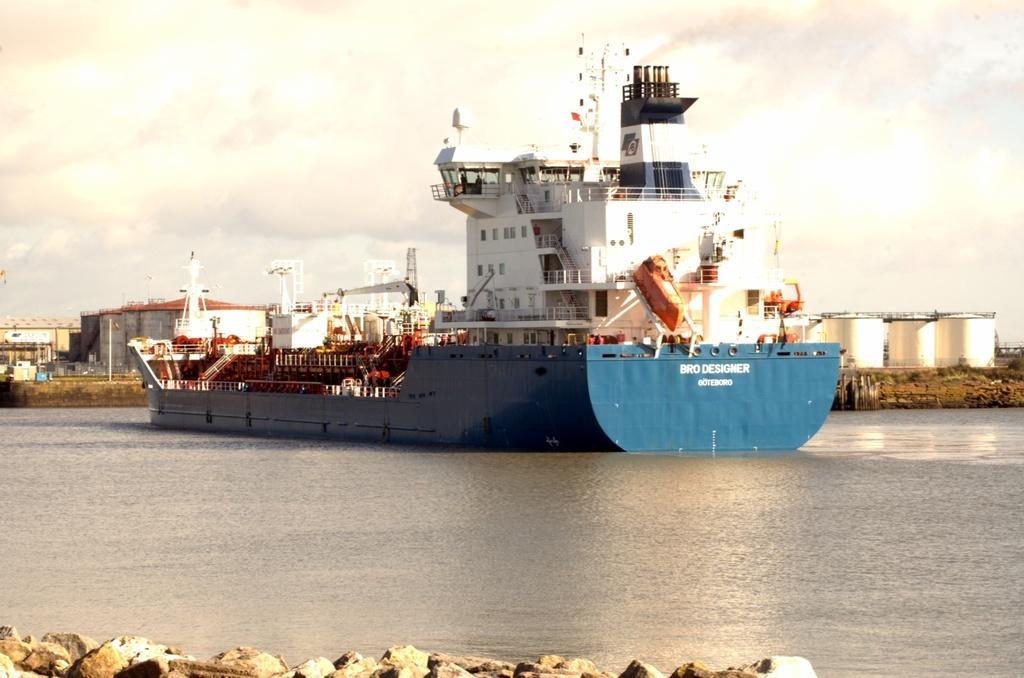Could you give a brief overview of what you see in this image? In this image there is a ship in the water. In the background there are so many factories. At the bottom there are stones. In the ship there is a building. There are few towers on the land. On the right side there are big containers on the ground. 